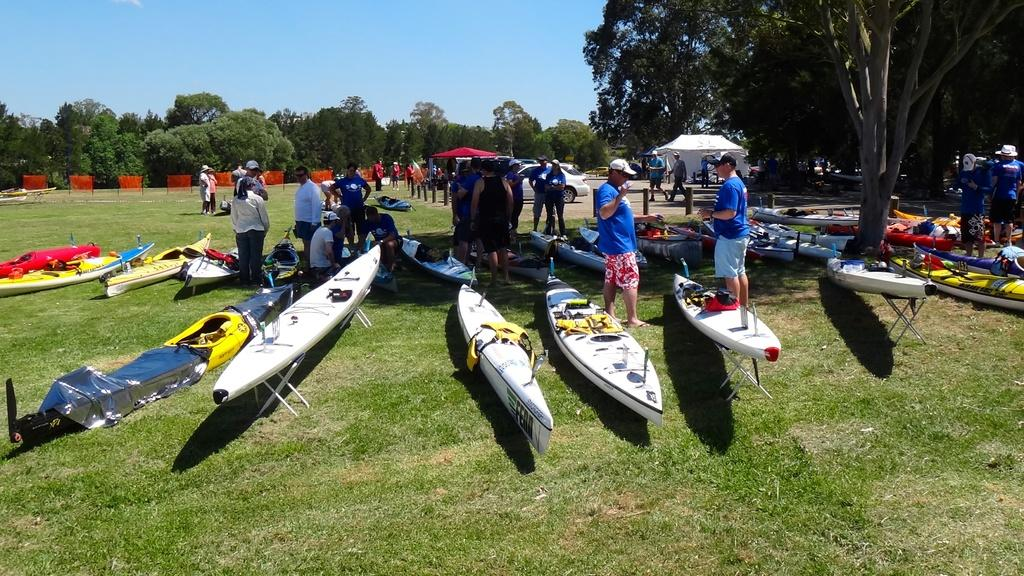What can be seen in the background of the image? There is a sky and trees visible in the background of the image. What type of terrain is present in the image? There is grass in the image. What structures are visible in the image? There are tents in the image. What mode of transportation is present in the image? There are vehicles in the image. What recreational equipment is present in the image? There are sea kayaks in the image. Who is present in the image? There are people in the image. What type of record is being played in the image? There is no record player or record visible in the image. What mathematical operation is being performed by the people in the image? There is no indication of any mathematical operation being performed by the people in the image. 